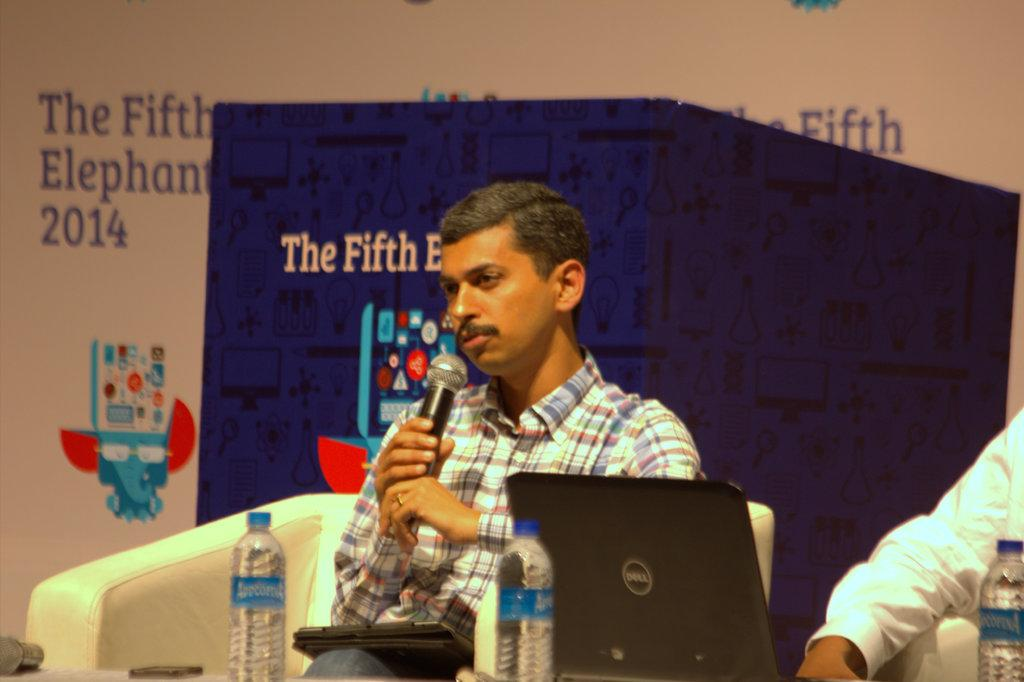What type of structure can be seen in the image? There is a wall in the image. What type of furniture is present in the image? There is a sofa in the image. What are the two people doing in the image? They are sitting on a table. What objects can be seen on the table? There are bottles and a laptop on the table. What is the person sitting in the middle holding? The person sitting in the middle is holding a mic. What type of stamp is visible on the wall in the image? There is no stamp visible on the wall in the image. What event is taking place in the image? The image does not depict a specific event; it shows two people sitting on a table with a laptop and bottles. 